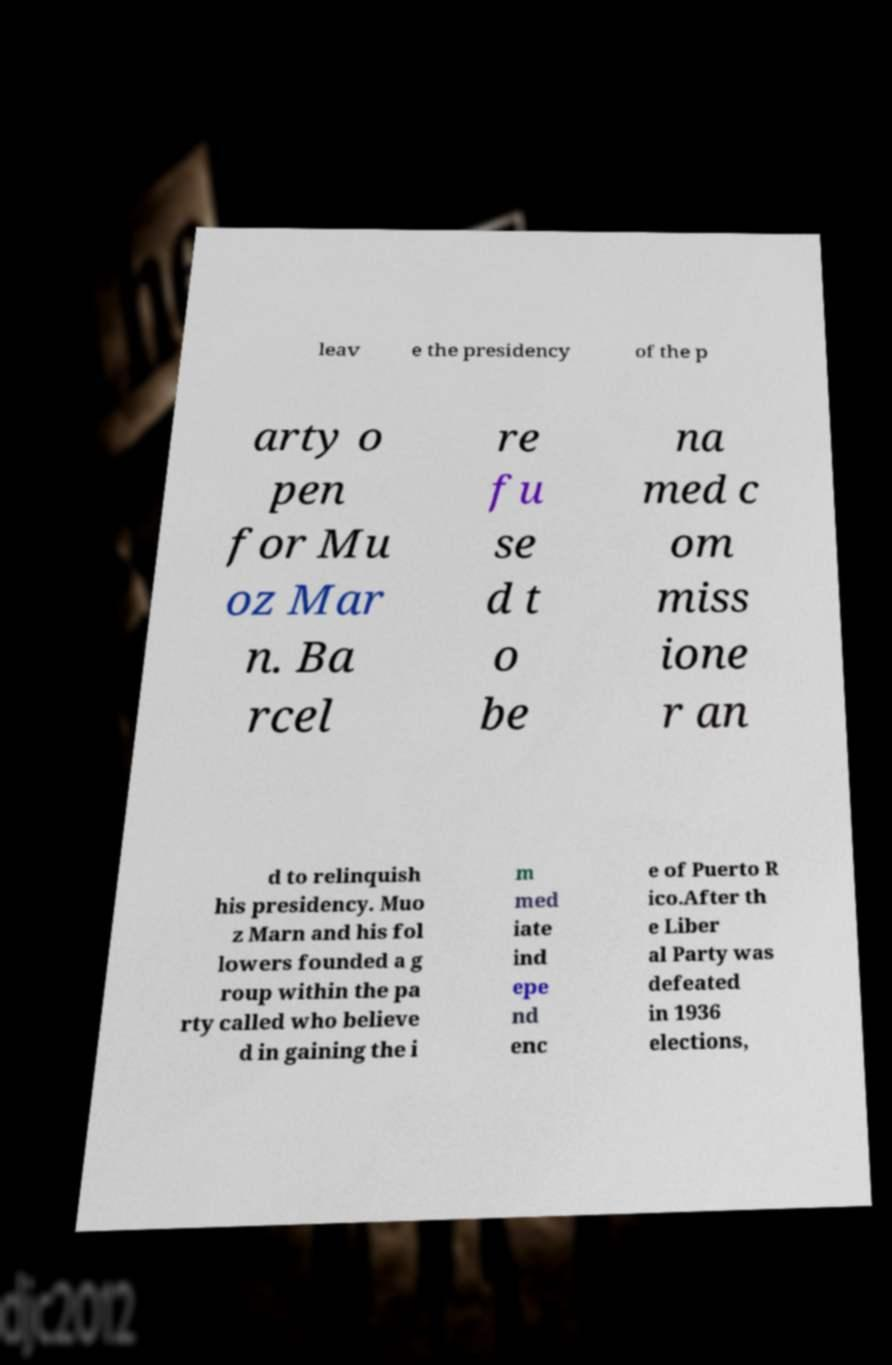Can you read and provide the text displayed in the image?This photo seems to have some interesting text. Can you extract and type it out for me? leav e the presidency of the p arty o pen for Mu oz Mar n. Ba rcel re fu se d t o be na med c om miss ione r an d to relinquish his presidency. Muo z Marn and his fol lowers founded a g roup within the pa rty called who believe d in gaining the i m med iate ind epe nd enc e of Puerto R ico.After th e Liber al Party was defeated in 1936 elections, 